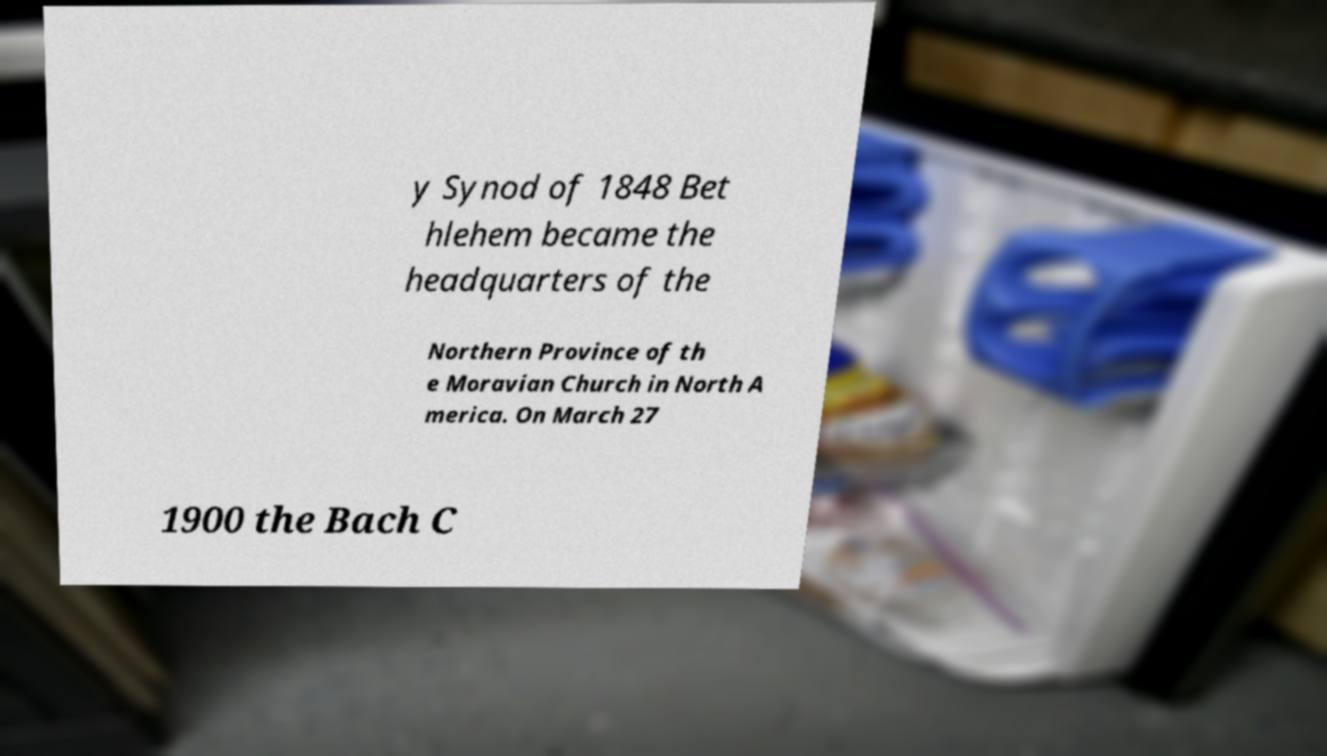I need the written content from this picture converted into text. Can you do that? y Synod of 1848 Bet hlehem became the headquarters of the Northern Province of th e Moravian Church in North A merica. On March 27 1900 the Bach C 